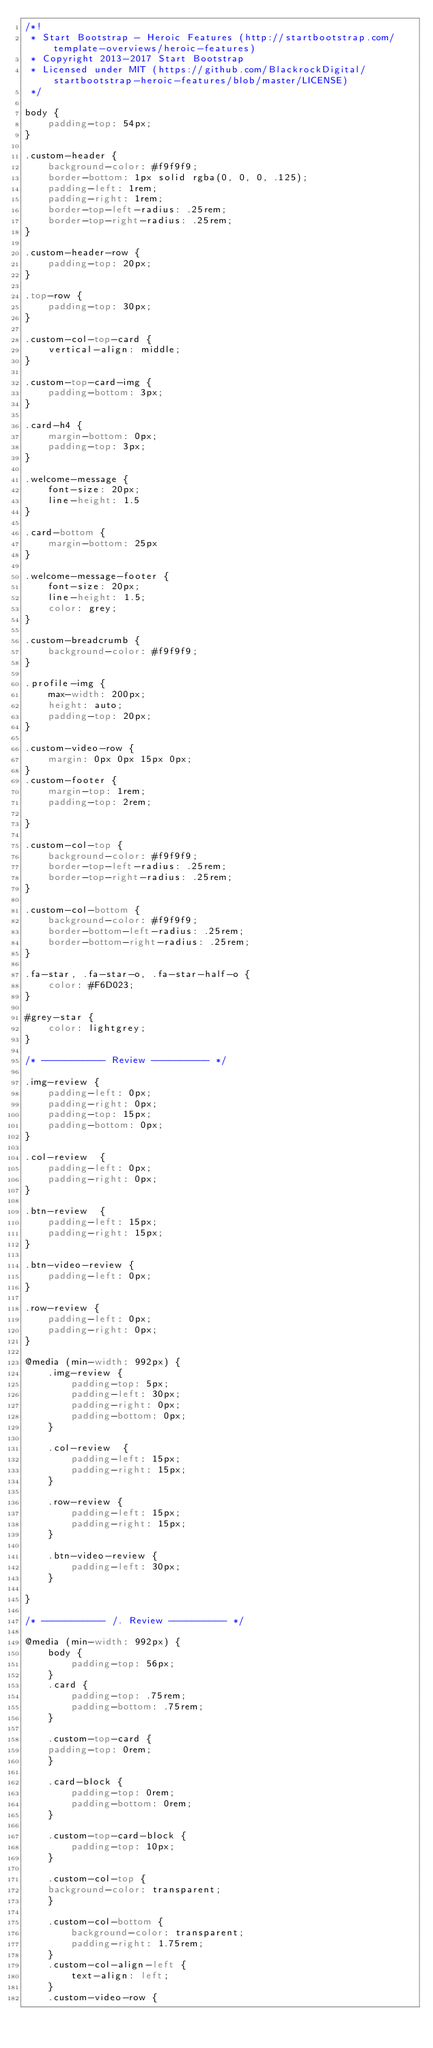Convert code to text. <code><loc_0><loc_0><loc_500><loc_500><_CSS_>/*!
 * Start Bootstrap - Heroic Features (http://startbootstrap.com/template-overviews/heroic-features)
 * Copyright 2013-2017 Start Bootstrap
 * Licensed under MIT (https://github.com/BlackrockDigital/startbootstrap-heroic-features/blob/master/LICENSE)
 */

body {
    padding-top: 54px;
}

.custom-header {
    background-color: #f9f9f9;
    border-bottom: 1px solid rgba(0, 0, 0, .125);
    padding-left: 1rem;
    padding-right: 1rem;
    border-top-left-radius: .25rem;
    border-top-right-radius: .25rem;
}

.custom-header-row {
    padding-top: 20px;
}

.top-row {
    padding-top: 30px;
}

.custom-col-top-card {
    vertical-align: middle;
}

.custom-top-card-img {
    padding-bottom: 3px;
}

.card-h4 {
    margin-bottom: 0px;
    padding-top: 3px;
}

.welcome-message {
    font-size: 20px;
    line-height: 1.5
}

.card-bottom {
    margin-bottom: 25px
}

.welcome-message-footer {
    font-size: 20px;
    line-height: 1.5;
    color: grey;
}

.custom-breadcrumb {
    background-color: #f9f9f9;
}

.profile-img {
    max-width: 200px;
    height: auto;
    padding-top: 20px;
}

.custom-video-row {
    margin: 0px 0px 15px 0px;
}
.custom-footer {
    margin-top: 1rem;
    padding-top: 2rem;

}

.custom-col-top {
    background-color: #f9f9f9;
    border-top-left-radius: .25rem;
    border-top-right-radius: .25rem;
}

.custom-col-bottom {
    background-color: #f9f9f9;
    border-bottom-left-radius: .25rem;
    border-bottom-right-radius: .25rem;
}

.fa-star, .fa-star-o, .fa-star-half-o {
    color: #F6D023;
}

#grey-star {
    color: lightgrey;
}

/* ----------- Review ---------- */

.img-review {
    padding-left: 0px;
    padding-right: 0px;
    padding-top: 15px;
    padding-bottom: 0px;
}

.col-review  {
    padding-left: 0px;
    padding-right: 0px;
}

.btn-review  {
    padding-left: 15px;
    padding-right: 15px;
}

.btn-video-review {
    padding-left: 0px;
}

.row-review {
    padding-left: 0px;
    padding-right: 0px;
}

@media (min-width: 992px) {
    .img-review {
        padding-top: 5px;
        padding-left: 30px;
        padding-right: 0px;
        padding-bottom: 0px;
    }
    
    .col-review  {
        padding-left: 15px;
        padding-right: 15px;
    }
    
    .row-review {
        padding-left: 15px;
        padding-right: 15px;
    }
    
    .btn-video-review {
        padding-left: 30px;
    }
    
}

/* ----------- /. Review ---------- */

@media (min-width: 992px) {
    body {
        padding-top: 56px;
    }
    .card {
        padding-top: .75rem;
        padding-bottom: .75rem;
    }
    
    .custom-top-card {
    padding-top: 0rem;
    }
    
    .card-block {
        padding-top: 0rem;
        padding-bottom: 0rem;
    }
    
    .custom-top-card-block {
        padding-top: 10px;
    }
    
    .custom-col-top {
    background-color: transparent;
    }

    .custom-col-bottom {
        background-color: transparent;
        padding-right: 1.75rem;
    }
    .custom-col-align-left {
        text-align: left;
    }
    .custom-video-row {</code> 